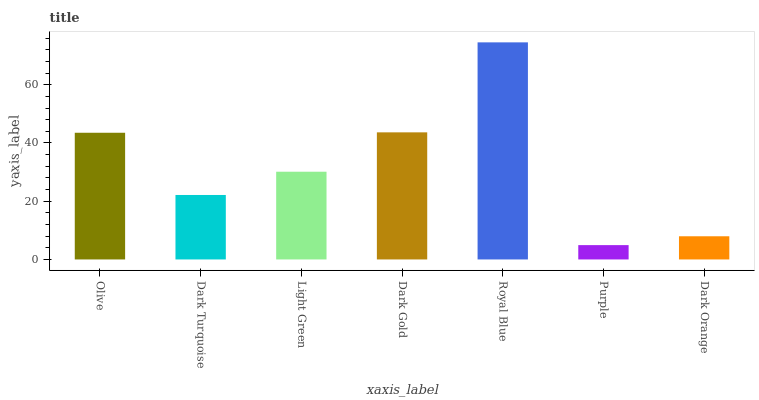Is Purple the minimum?
Answer yes or no. Yes. Is Royal Blue the maximum?
Answer yes or no. Yes. Is Dark Turquoise the minimum?
Answer yes or no. No. Is Dark Turquoise the maximum?
Answer yes or no. No. Is Olive greater than Dark Turquoise?
Answer yes or no. Yes. Is Dark Turquoise less than Olive?
Answer yes or no. Yes. Is Dark Turquoise greater than Olive?
Answer yes or no. No. Is Olive less than Dark Turquoise?
Answer yes or no. No. Is Light Green the high median?
Answer yes or no. Yes. Is Light Green the low median?
Answer yes or no. Yes. Is Dark Turquoise the high median?
Answer yes or no. No. Is Dark Orange the low median?
Answer yes or no. No. 